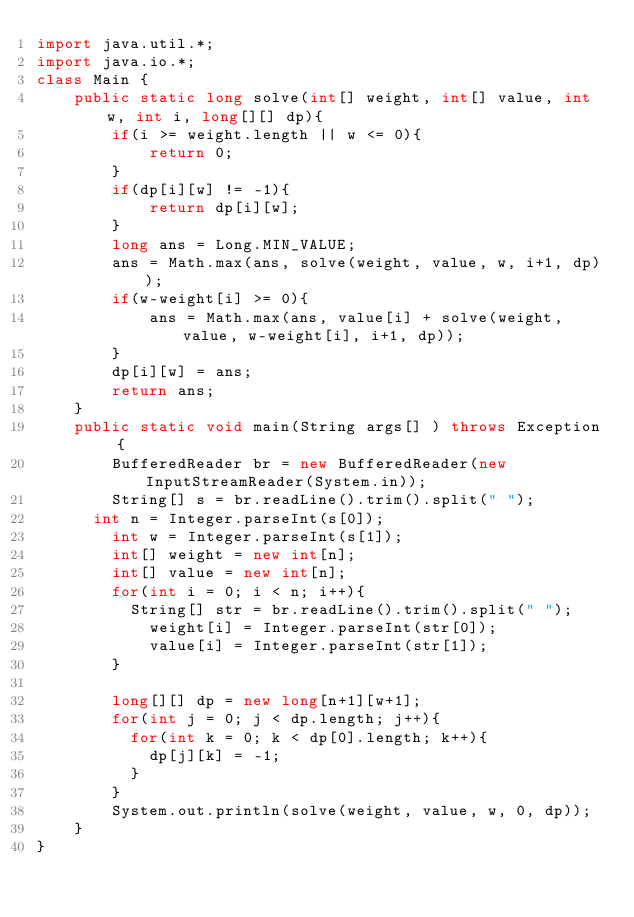Convert code to text. <code><loc_0><loc_0><loc_500><loc_500><_Java_>import java.util.*;
import java.io.*;
class Main {
    public static long solve(int[] weight, int[] value, int w, int i, long[][] dp){
        if(i >= weight.length || w <= 0){
            return 0;
        }
        if(dp[i][w] != -1){
            return dp[i][w];
        }
        long ans = Long.MIN_VALUE;
        ans = Math.max(ans, solve(weight, value, w, i+1, dp));
        if(w-weight[i] >= 0){
            ans = Math.max(ans, value[i] + solve(weight, value, w-weight[i], i+1, dp));
        }
        dp[i][w] = ans;
        return ans;
    }
    public static void main(String args[] ) throws Exception {
        BufferedReader br = new BufferedReader(new InputStreamReader(System.in));
      	String[] s = br.readLine().trim().split(" ");
  		int n = Integer.parseInt(s[0]);
        int w = Integer.parseInt(s[1]);
      	int[] weight = new int[n];
        int[] value = new int[n];
        for(int i = 0; i < n; i++){
        	String[] str = br.readLine().trim().split(" ");
          	weight[i] = Integer.parseInt(str[0]);
          	value[i] = Integer.parseInt(str[1]);
        }
        
        long[][] dp = new long[n+1][w+1];
        for(int j = 0; j < dp.length; j++){
          for(int k = 0; k < dp[0].length; k++){
            dp[j][k] = -1;
          }
        }
        System.out.println(solve(weight, value, w, 0, dp));
    }
}
</code> 